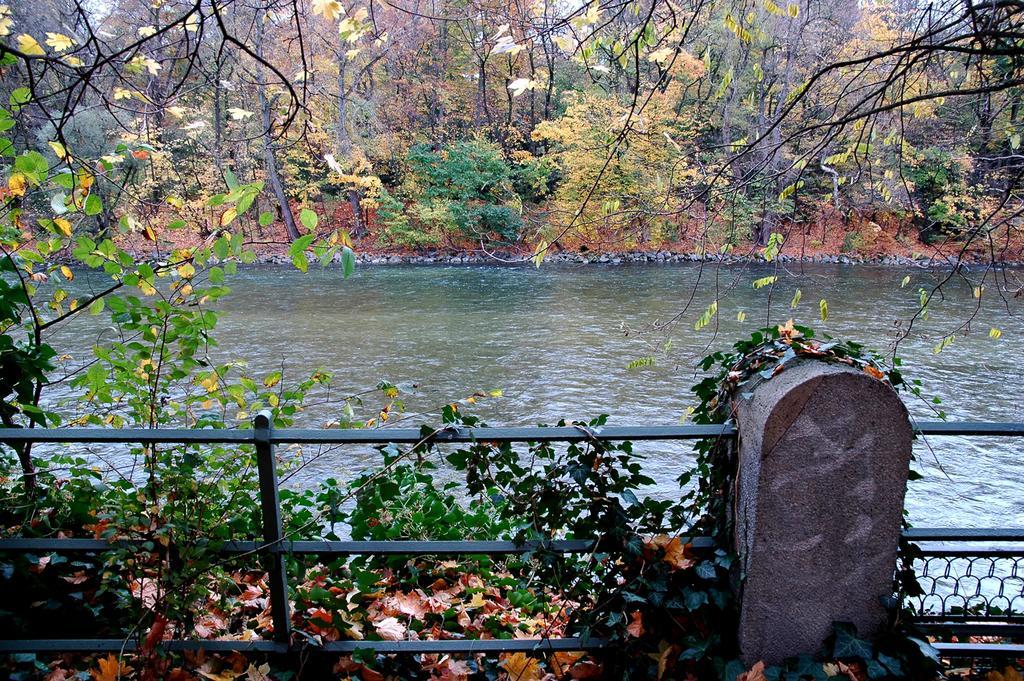How would you summarize this image in a sentence or two? This image consists of trees at the top. There is water in the middle. There is sky at the top. 